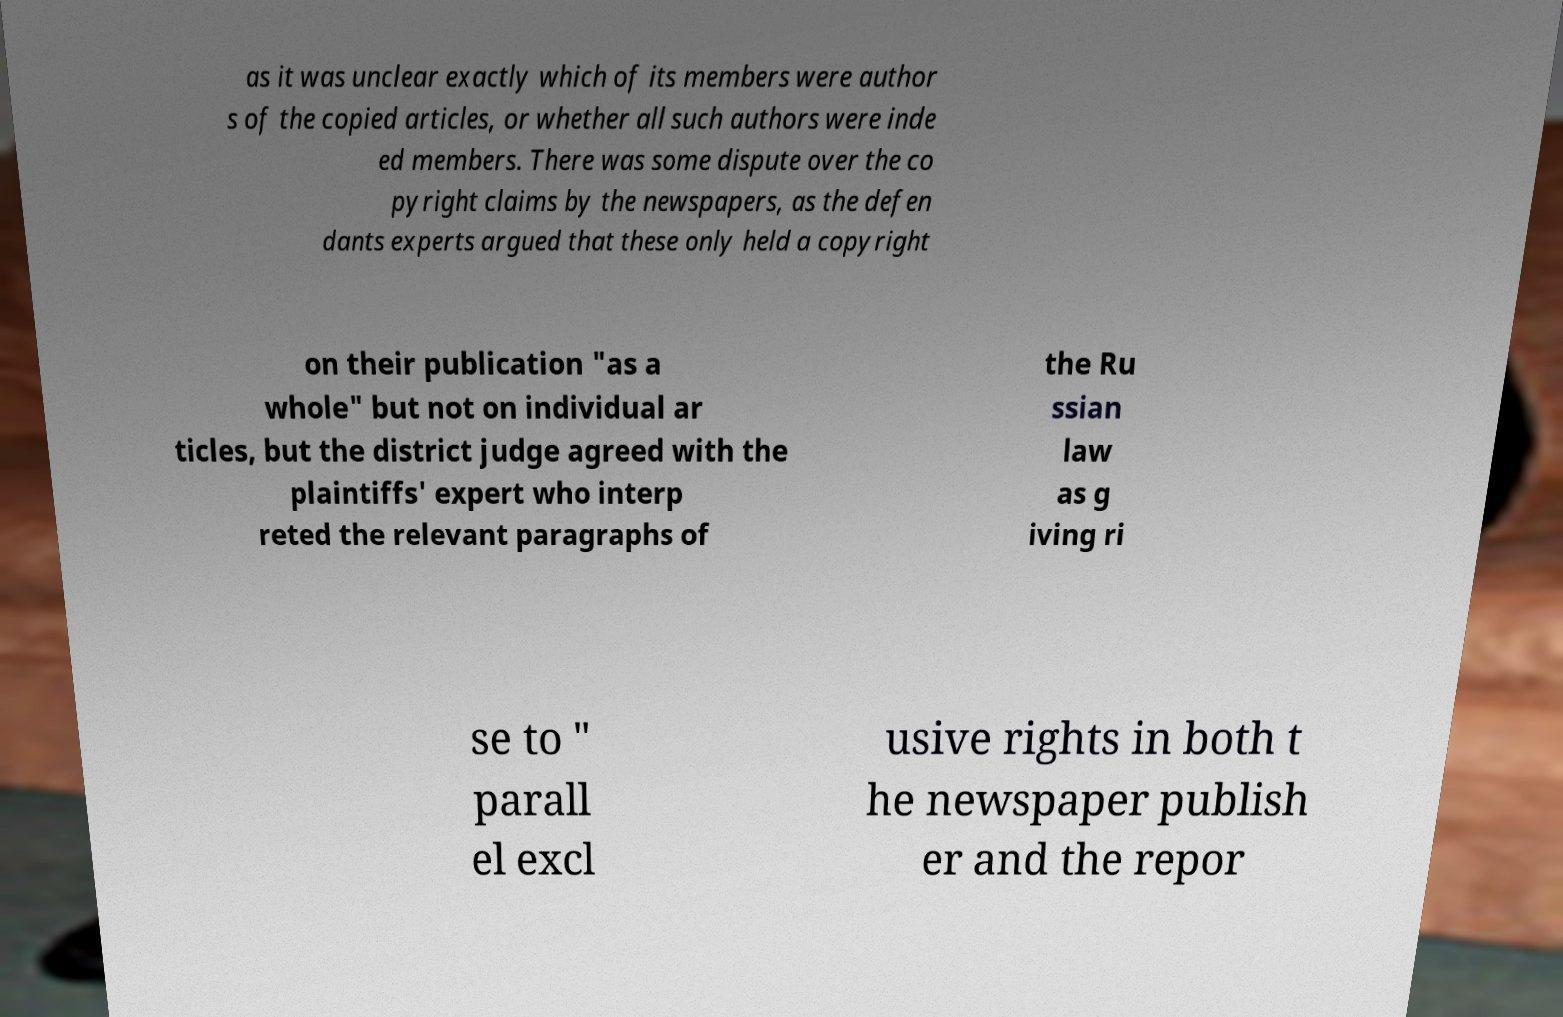Can you accurately transcribe the text from the provided image for me? as it was unclear exactly which of its members were author s of the copied articles, or whether all such authors were inde ed members. There was some dispute over the co pyright claims by the newspapers, as the defen dants experts argued that these only held a copyright on their publication "as a whole" but not on individual ar ticles, but the district judge agreed with the plaintiffs' expert who interp reted the relevant paragraphs of the Ru ssian law as g iving ri se to " parall el excl usive rights in both t he newspaper publish er and the repor 